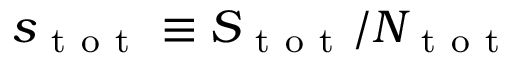Convert formula to latex. <formula><loc_0><loc_0><loc_500><loc_500>s _ { t o t } \equiv S _ { t o t } / N _ { t o t }</formula> 